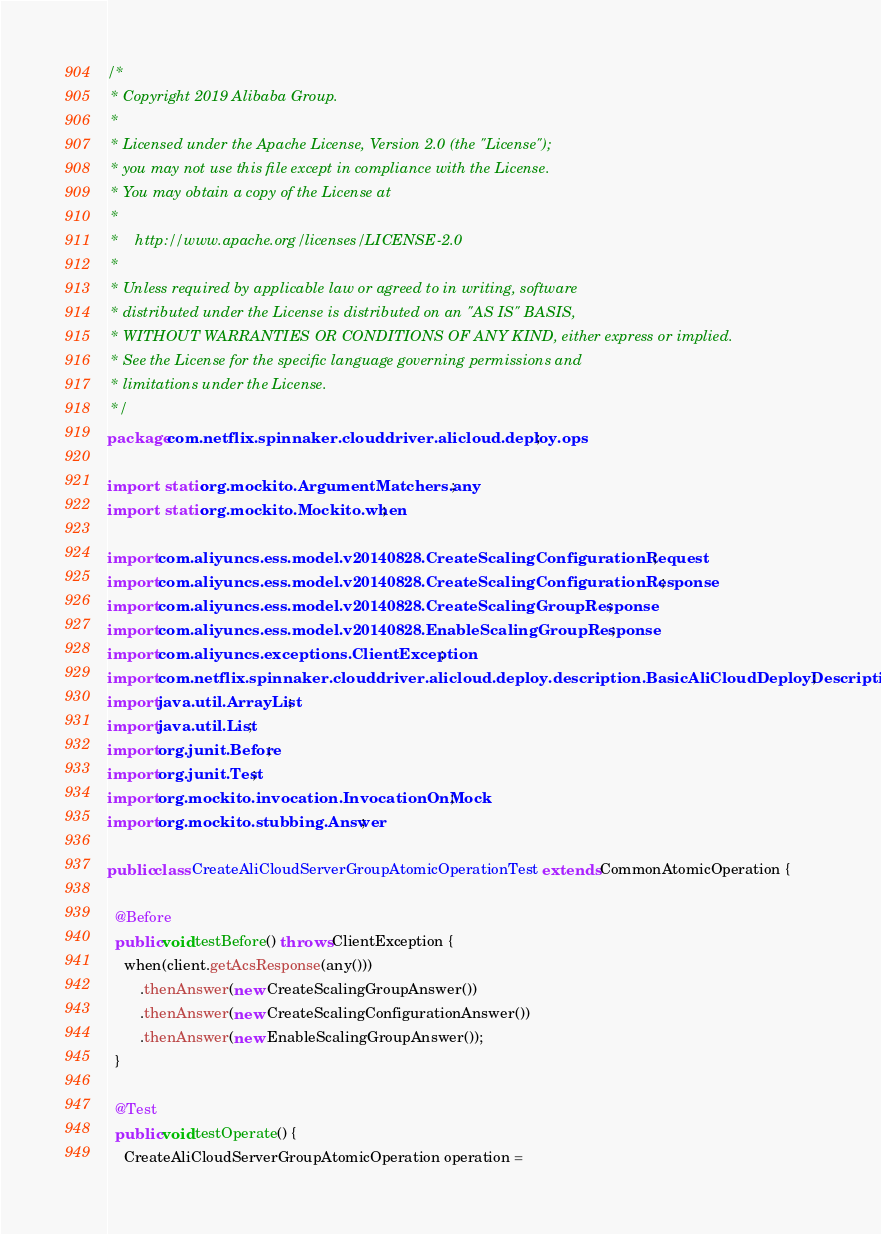Convert code to text. <code><loc_0><loc_0><loc_500><loc_500><_Java_>/*
 * Copyright 2019 Alibaba Group.
 *
 * Licensed under the Apache License, Version 2.0 (the "License");
 * you may not use this file except in compliance with the License.
 * You may obtain a copy of the License at
 *
 *    http://www.apache.org/licenses/LICENSE-2.0
 *
 * Unless required by applicable law or agreed to in writing, software
 * distributed under the License is distributed on an "AS IS" BASIS,
 * WITHOUT WARRANTIES OR CONDITIONS OF ANY KIND, either express or implied.
 * See the License for the specific language governing permissions and
 * limitations under the License.
 */
package com.netflix.spinnaker.clouddriver.alicloud.deploy.ops;

import static org.mockito.ArgumentMatchers.any;
import static org.mockito.Mockito.when;

import com.aliyuncs.ess.model.v20140828.CreateScalingConfigurationRequest;
import com.aliyuncs.ess.model.v20140828.CreateScalingConfigurationResponse;
import com.aliyuncs.ess.model.v20140828.CreateScalingGroupResponse;
import com.aliyuncs.ess.model.v20140828.EnableScalingGroupResponse;
import com.aliyuncs.exceptions.ClientException;
import com.netflix.spinnaker.clouddriver.alicloud.deploy.description.BasicAliCloudDeployDescription;
import java.util.ArrayList;
import java.util.List;
import org.junit.Before;
import org.junit.Test;
import org.mockito.invocation.InvocationOnMock;
import org.mockito.stubbing.Answer;

public class CreateAliCloudServerGroupAtomicOperationTest extends CommonAtomicOperation {

  @Before
  public void testBefore() throws ClientException {
    when(client.getAcsResponse(any()))
        .thenAnswer(new CreateScalingGroupAnswer())
        .thenAnswer(new CreateScalingConfigurationAnswer())
        .thenAnswer(new EnableScalingGroupAnswer());
  }

  @Test
  public void testOperate() {
    CreateAliCloudServerGroupAtomicOperation operation =</code> 